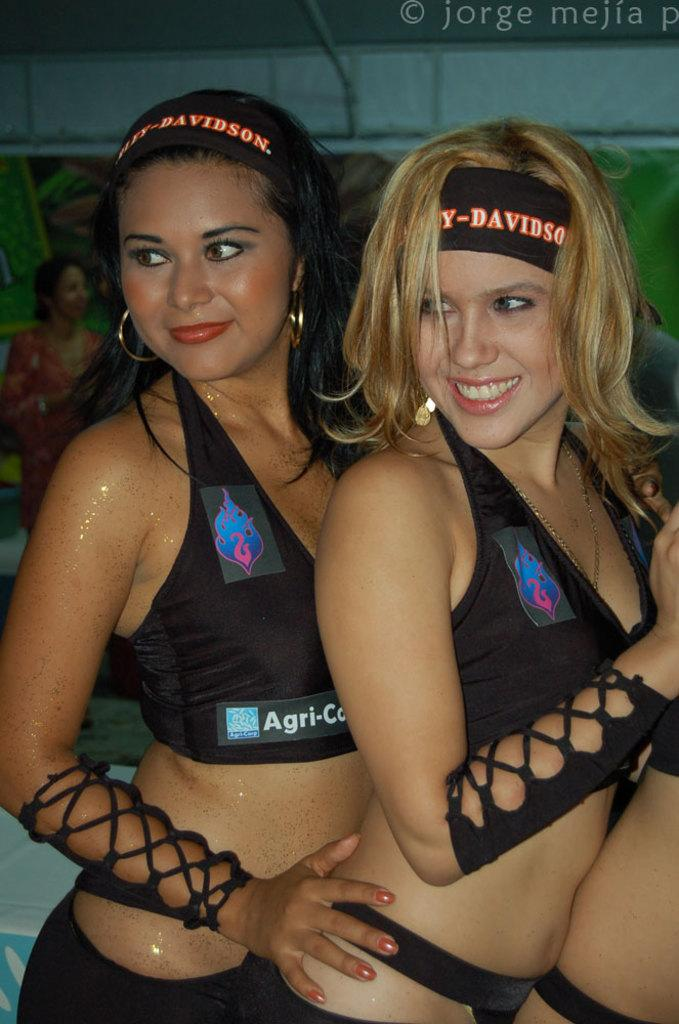<image>
Give a short and clear explanation of the subsequent image. two women with Harley-Davidson head bands holding each other 